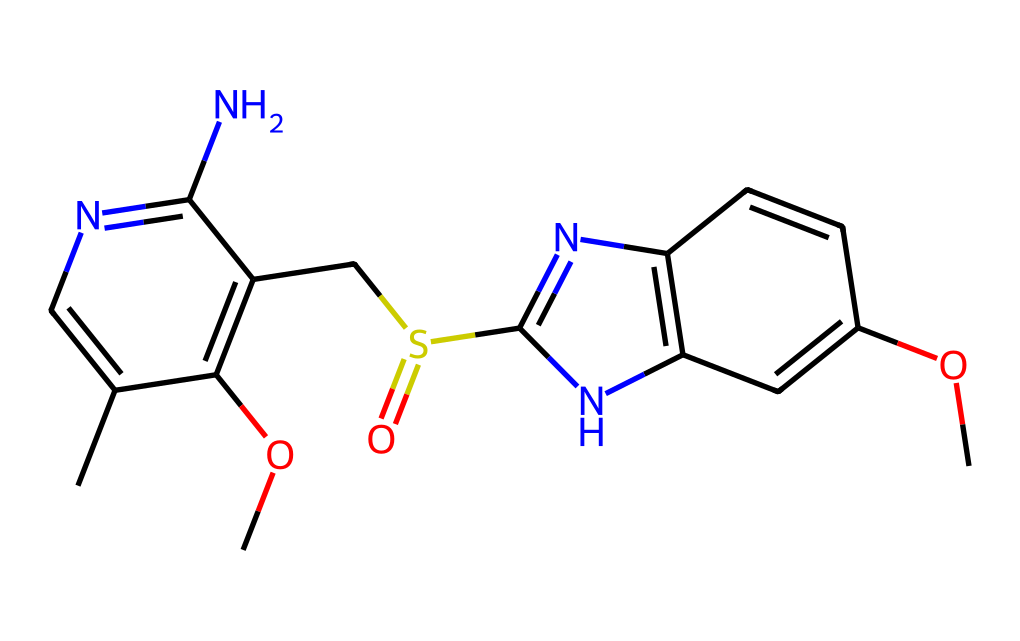What is the molecular formula of omeprazole? The elements present in the chemical structure can be identified from the SMILES representation, counting the carbon (C), hydrogen (H), nitrogen (N), oxygen (O), and sulfur (S) atoms. From the provided SMILES, there are 17 carbon atoms, 19 hydrogen atoms, 3 nitrogen atoms, 4 oxygen atoms, and 1 sulfur atom, leading to the molecular formula C17H19N3O4S.
Answer: C17H19N3O4S How many chiral centers are present in omeprazole? By analyzing the SMILES structure for tetrahedral carbon atoms where four different substituents are attached, we can identify the chiral centers. In the provided structure of omeprazole, there is one such carbon, indicating the presence of one chiral center.
Answer: 1 Is omeprazole a racemic mixture? A racemic mixture contains equal amounts of both enantiomers. Omeprazole, being a chiral compound with one chiral center, actually exists as a racemic mixture comprising equal parts of its enantiomers, S-omeprazole and R-omeprazole.
Answer: Yes What type of chemical bond connects the carbon and nitrogen atoms in omeprazole? The bond connecting carbon and nitrogen atoms in the structure can be typically observed as either single or double. In this case, examining the structure will show that carbon forms single bonds with nitrogen in multiple locations, indicative of amine type linkages.
Answer: Single bond Which functional groups are present in omeprazole? A thorough review of the SMILES will reveal various functional groups based on the atoms and their connections. In omeprazole, the presence of a sulfone group (S=O), methoxy groups (-OCH3), and an imidazole ring highlights its functional diversity.
Answer: Methoxy, sulfone, imidazole 